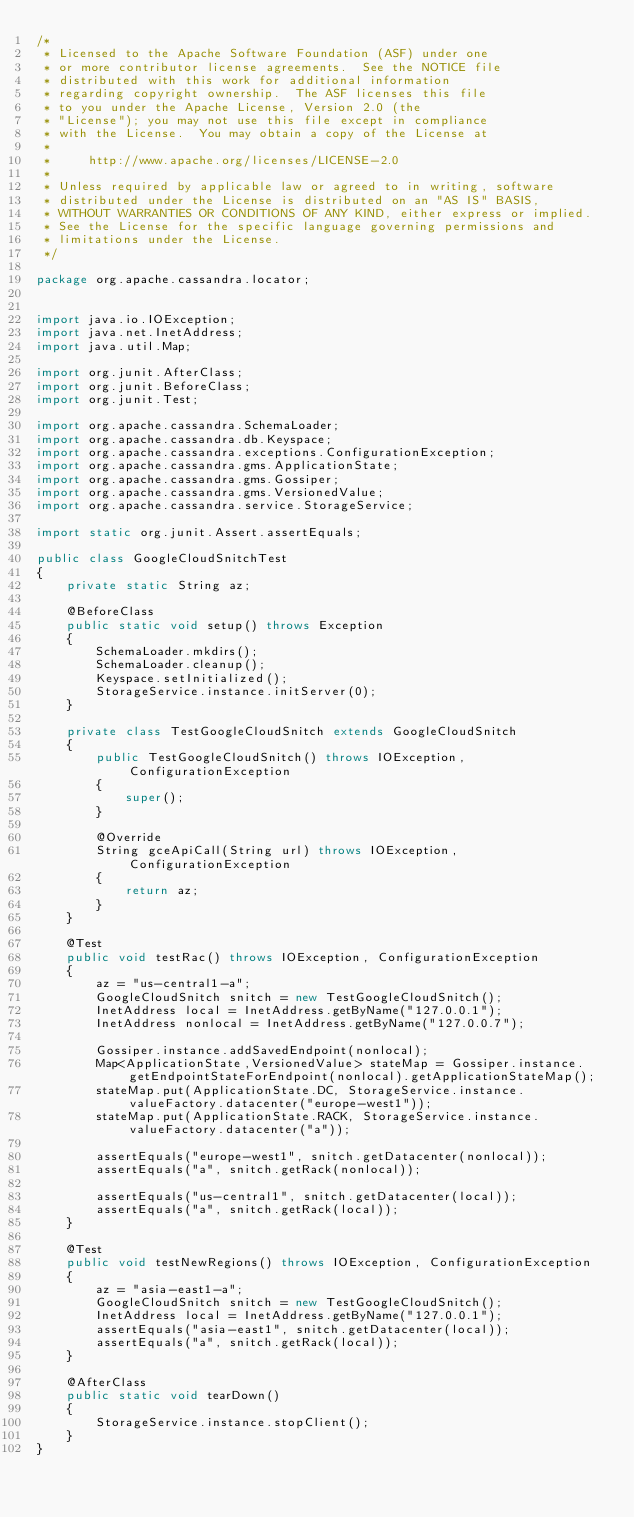<code> <loc_0><loc_0><loc_500><loc_500><_Java_>/*
 * Licensed to the Apache Software Foundation (ASF) under one
 * or more contributor license agreements.  See the NOTICE file
 * distributed with this work for additional information
 * regarding copyright ownership.  The ASF licenses this file
 * to you under the Apache License, Version 2.0 (the
 * "License"); you may not use this file except in compliance
 * with the License.  You may obtain a copy of the License at
 *
 *     http://www.apache.org/licenses/LICENSE-2.0
 *
 * Unless required by applicable law or agreed to in writing, software
 * distributed under the License is distributed on an "AS IS" BASIS,
 * WITHOUT WARRANTIES OR CONDITIONS OF ANY KIND, either express or implied.
 * See the License for the specific language governing permissions and
 * limitations under the License.
 */

package org.apache.cassandra.locator;


import java.io.IOException;
import java.net.InetAddress;
import java.util.Map;

import org.junit.AfterClass;
import org.junit.BeforeClass;
import org.junit.Test;

import org.apache.cassandra.SchemaLoader;
import org.apache.cassandra.db.Keyspace;
import org.apache.cassandra.exceptions.ConfigurationException;
import org.apache.cassandra.gms.ApplicationState;
import org.apache.cassandra.gms.Gossiper;
import org.apache.cassandra.gms.VersionedValue;
import org.apache.cassandra.service.StorageService;

import static org.junit.Assert.assertEquals;

public class GoogleCloudSnitchTest
{
    private static String az;

    @BeforeClass
    public static void setup() throws Exception
    {
        SchemaLoader.mkdirs();
        SchemaLoader.cleanup();
        Keyspace.setInitialized();
        StorageService.instance.initServer(0);
    }

    private class TestGoogleCloudSnitch extends GoogleCloudSnitch
    {
        public TestGoogleCloudSnitch() throws IOException, ConfigurationException
        {
            super();
        }

        @Override
        String gceApiCall(String url) throws IOException, ConfigurationException
        {
            return az;
        }
    }

    @Test
    public void testRac() throws IOException, ConfigurationException
    {
        az = "us-central1-a";
        GoogleCloudSnitch snitch = new TestGoogleCloudSnitch();
        InetAddress local = InetAddress.getByName("127.0.0.1");
        InetAddress nonlocal = InetAddress.getByName("127.0.0.7");

        Gossiper.instance.addSavedEndpoint(nonlocal);
        Map<ApplicationState,VersionedValue> stateMap = Gossiper.instance.getEndpointStateForEndpoint(nonlocal).getApplicationStateMap();
        stateMap.put(ApplicationState.DC, StorageService.instance.valueFactory.datacenter("europe-west1"));
        stateMap.put(ApplicationState.RACK, StorageService.instance.valueFactory.datacenter("a"));

        assertEquals("europe-west1", snitch.getDatacenter(nonlocal));
        assertEquals("a", snitch.getRack(nonlocal));

        assertEquals("us-central1", snitch.getDatacenter(local));
        assertEquals("a", snitch.getRack(local));
    }
    
    @Test
    public void testNewRegions() throws IOException, ConfigurationException
    {
        az = "asia-east1-a";
        GoogleCloudSnitch snitch = new TestGoogleCloudSnitch();
        InetAddress local = InetAddress.getByName("127.0.0.1");
        assertEquals("asia-east1", snitch.getDatacenter(local));
        assertEquals("a", snitch.getRack(local));
    }

    @AfterClass
    public static void tearDown()
    {
        StorageService.instance.stopClient();
    }
}
</code> 